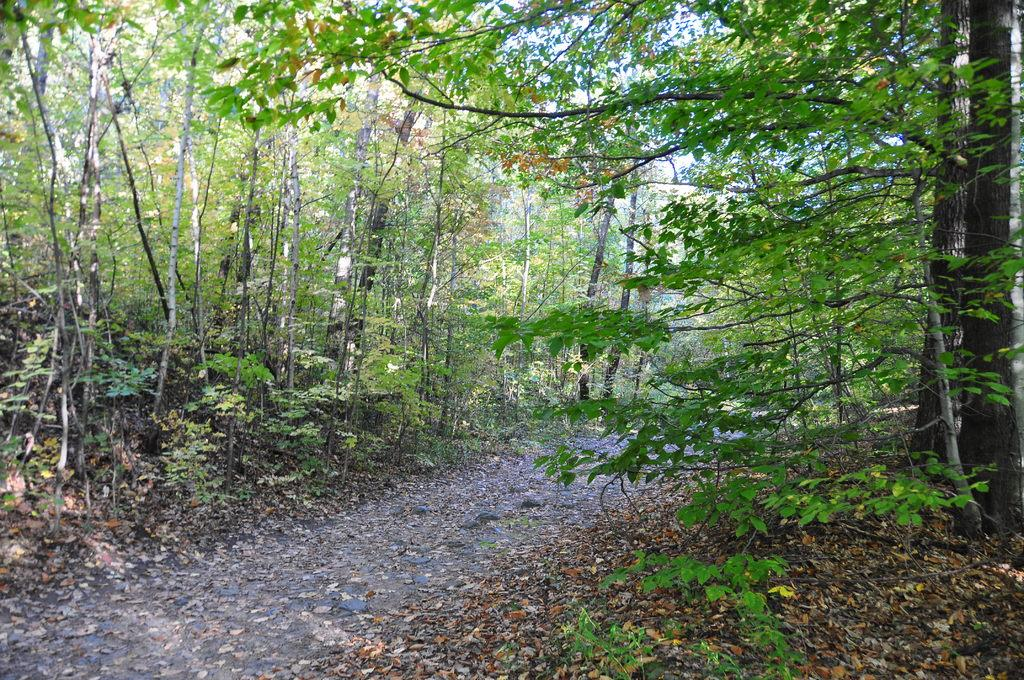What can be seen in the image that people might walk on? There is a path in the image that people might walk on. What is covering the ground near the path? There are leaves on the ground near the path. What type of vegetation is present on either side of the path? Trees are present on either side of the path. What is visible in the sky in the background of the image? There are clouds in the sky in the background of the image. Can you see a group of fairies flying around the trees in the image? There are no fairies present in the image; it only shows a path, leaves on the ground, trees, and clouds in the sky. 